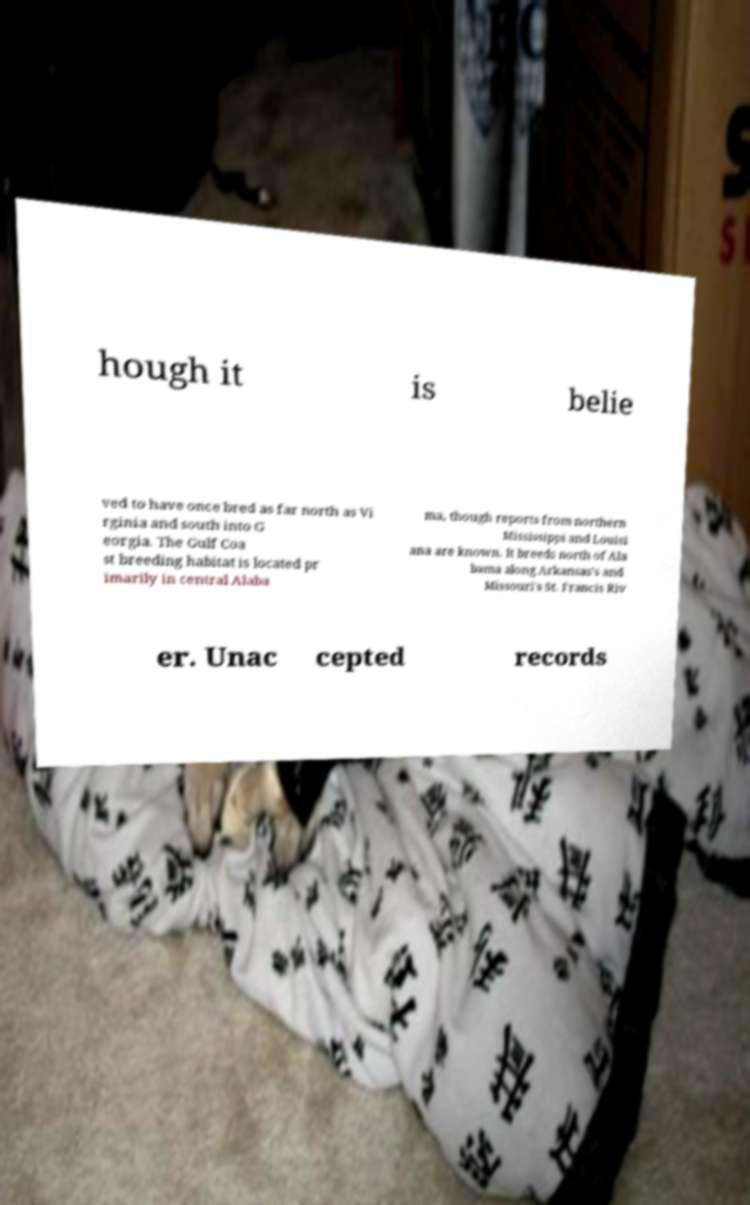There's text embedded in this image that I need extracted. Can you transcribe it verbatim? hough it is belie ved to have once bred as far north as Vi rginia and south into G eorgia. The Gulf Coa st breeding habitat is located pr imarily in central Alaba ma, though reports from northern Mississippi and Louisi ana are known. It breeds north of Ala bama along Arkansas's and Missouri's St. Francis Riv er. Unac cepted records 